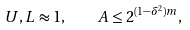<formula> <loc_0><loc_0><loc_500><loc_500>U , L \approx 1 , \quad A \leq 2 ^ { ( 1 - \delta ^ { 2 } ) m } ,</formula> 